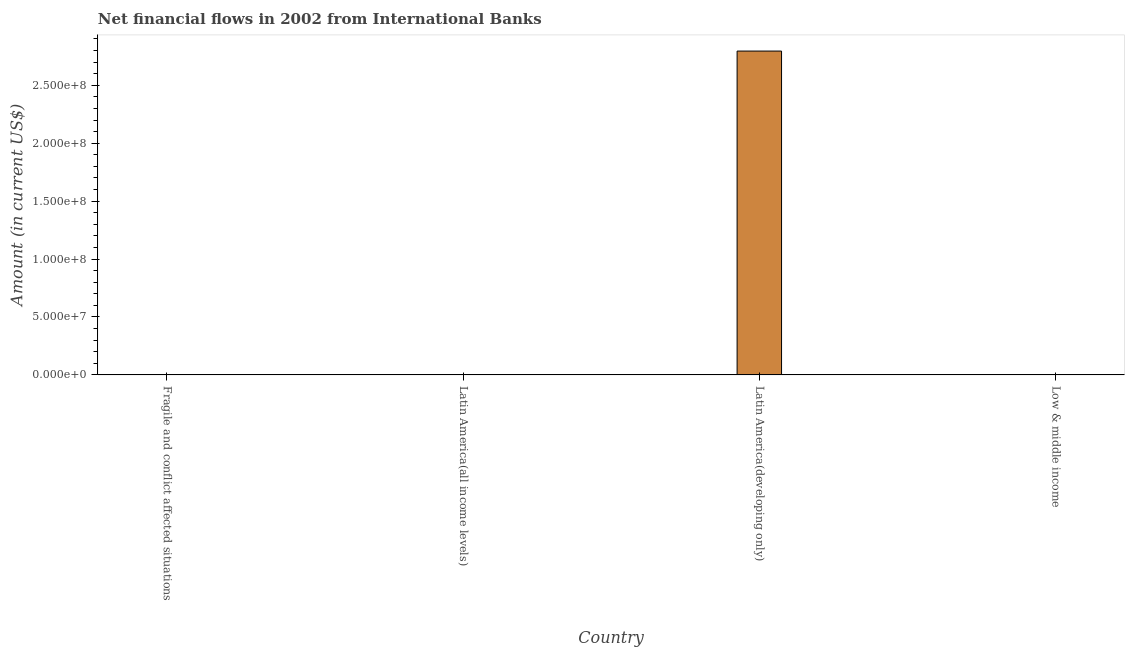Does the graph contain any zero values?
Provide a succinct answer. Yes. What is the title of the graph?
Give a very brief answer. Net financial flows in 2002 from International Banks. What is the label or title of the Y-axis?
Make the answer very short. Amount (in current US$). What is the net financial flows from ibrd in Latin America(all income levels)?
Your response must be concise. 0. Across all countries, what is the maximum net financial flows from ibrd?
Ensure brevity in your answer.  2.80e+08. In which country was the net financial flows from ibrd maximum?
Your response must be concise. Latin America(developing only). What is the sum of the net financial flows from ibrd?
Provide a succinct answer. 2.80e+08. What is the average net financial flows from ibrd per country?
Your answer should be very brief. 6.99e+07. What is the difference between the highest and the lowest net financial flows from ibrd?
Offer a terse response. 2.80e+08. Are all the bars in the graph horizontal?
Offer a terse response. No. How many countries are there in the graph?
Offer a very short reply. 4. Are the values on the major ticks of Y-axis written in scientific E-notation?
Your answer should be very brief. Yes. What is the Amount (in current US$) of Latin America(developing only)?
Keep it short and to the point. 2.80e+08. 